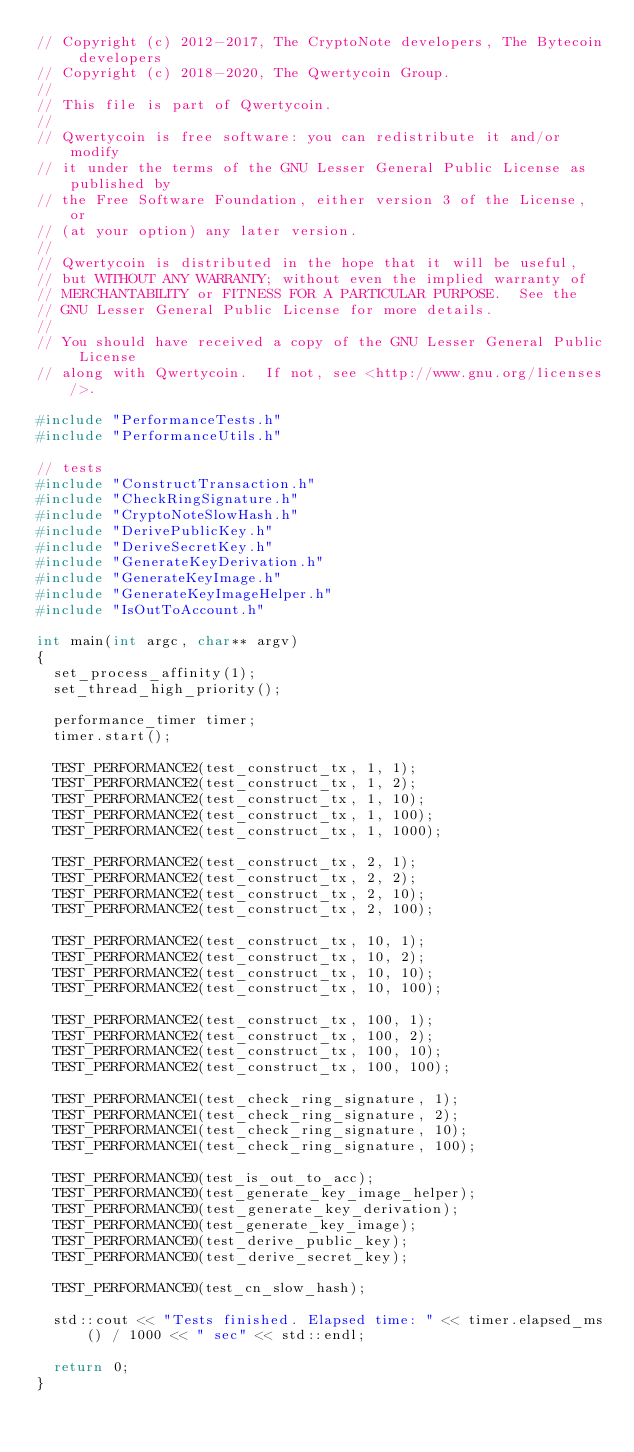Convert code to text. <code><loc_0><loc_0><loc_500><loc_500><_C++_>// Copyright (c) 2012-2017, The CryptoNote developers, The Bytecoin developers
// Copyright (c) 2018-2020, The Qwertycoin Group.
//
// This file is part of Qwertycoin.
//
// Qwertycoin is free software: you can redistribute it and/or modify
// it under the terms of the GNU Lesser General Public License as published by
// the Free Software Foundation, either version 3 of the License, or
// (at your option) any later version.
//
// Qwertycoin is distributed in the hope that it will be useful,
// but WITHOUT ANY WARRANTY; without even the implied warranty of
// MERCHANTABILITY or FITNESS FOR A PARTICULAR PURPOSE.  See the
// GNU Lesser General Public License for more details.
//
// You should have received a copy of the GNU Lesser General Public License
// along with Qwertycoin.  If not, see <http://www.gnu.org/licenses/>.

#include "PerformanceTests.h"
#include "PerformanceUtils.h"

// tests
#include "ConstructTransaction.h"
#include "CheckRingSignature.h"
#include "CryptoNoteSlowHash.h"
#include "DerivePublicKey.h"
#include "DeriveSecretKey.h"
#include "GenerateKeyDerivation.h"
#include "GenerateKeyImage.h"
#include "GenerateKeyImageHelper.h"
#include "IsOutToAccount.h"

int main(int argc, char** argv)
{
  set_process_affinity(1);
  set_thread_high_priority();

  performance_timer timer;
  timer.start();

  TEST_PERFORMANCE2(test_construct_tx, 1, 1);
  TEST_PERFORMANCE2(test_construct_tx, 1, 2);
  TEST_PERFORMANCE2(test_construct_tx, 1, 10);
  TEST_PERFORMANCE2(test_construct_tx, 1, 100);
  TEST_PERFORMANCE2(test_construct_tx, 1, 1000);

  TEST_PERFORMANCE2(test_construct_tx, 2, 1);
  TEST_PERFORMANCE2(test_construct_tx, 2, 2);
  TEST_PERFORMANCE2(test_construct_tx, 2, 10);
  TEST_PERFORMANCE2(test_construct_tx, 2, 100);

  TEST_PERFORMANCE2(test_construct_tx, 10, 1);
  TEST_PERFORMANCE2(test_construct_tx, 10, 2);
  TEST_PERFORMANCE2(test_construct_tx, 10, 10);
  TEST_PERFORMANCE2(test_construct_tx, 10, 100);

  TEST_PERFORMANCE2(test_construct_tx, 100, 1);
  TEST_PERFORMANCE2(test_construct_tx, 100, 2);
  TEST_PERFORMANCE2(test_construct_tx, 100, 10);
  TEST_PERFORMANCE2(test_construct_tx, 100, 100);

  TEST_PERFORMANCE1(test_check_ring_signature, 1);
  TEST_PERFORMANCE1(test_check_ring_signature, 2);
  TEST_PERFORMANCE1(test_check_ring_signature, 10);
  TEST_PERFORMANCE1(test_check_ring_signature, 100);

  TEST_PERFORMANCE0(test_is_out_to_acc);
  TEST_PERFORMANCE0(test_generate_key_image_helper);
  TEST_PERFORMANCE0(test_generate_key_derivation);
  TEST_PERFORMANCE0(test_generate_key_image);
  TEST_PERFORMANCE0(test_derive_public_key);
  TEST_PERFORMANCE0(test_derive_secret_key);

  TEST_PERFORMANCE0(test_cn_slow_hash);

  std::cout << "Tests finished. Elapsed time: " << timer.elapsed_ms() / 1000 << " sec" << std::endl;

  return 0;
}
</code> 